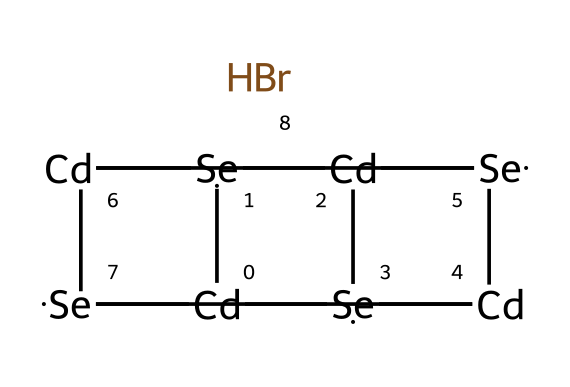What is the central atom in this structure? In the provided SMILES, "Cd" represents cadmium, which serves as the central atom surrounded by selenium atoms. Cadmium forms the core structure of the quantum dot.
Answer: cadmium How many selenium (Se) atoms are present in this molecule? By analyzing the SMILES representation, we count the instances of "Se," which appear five times. This indicates there are five selenium atoms in the entire compound.
Answer: five What is the role of bromine (Br) in this structure? Bromine is attached at the end of the structure and typically serves as a surface passivating agent in quantum dots to enhance stability and optical properties.
Answer: passivation What type of bonding can be expected in this compound? The structure shows multiple metal (Cd) and non-metal (Se, Br) combinations, indicating both covalent and ionic characteristics due to the interplay between electrons.
Answer: covalent and ionic How many cadmium (Cd) atoms are there in this quantum dot? Counting the occurrences of "Cd" in the SMILES results in four appearances of cadmium, indicating that there are four cadmium atoms present in the structure.
Answer: four What is the significance of using bromine in quantum dots? Bromine enhances the electronic and optical characteristics of the quantum dots, improving their performance in LED applications and modifying their band gap.
Answer: enhances performance What type of chemical species does this structure represent? The presence of cadmium selenide (represented by Cd and Se) along with bromine indicates that this structure is categorized as a semiconductor quantum dot.
Answer: semiconductor quantum dot 